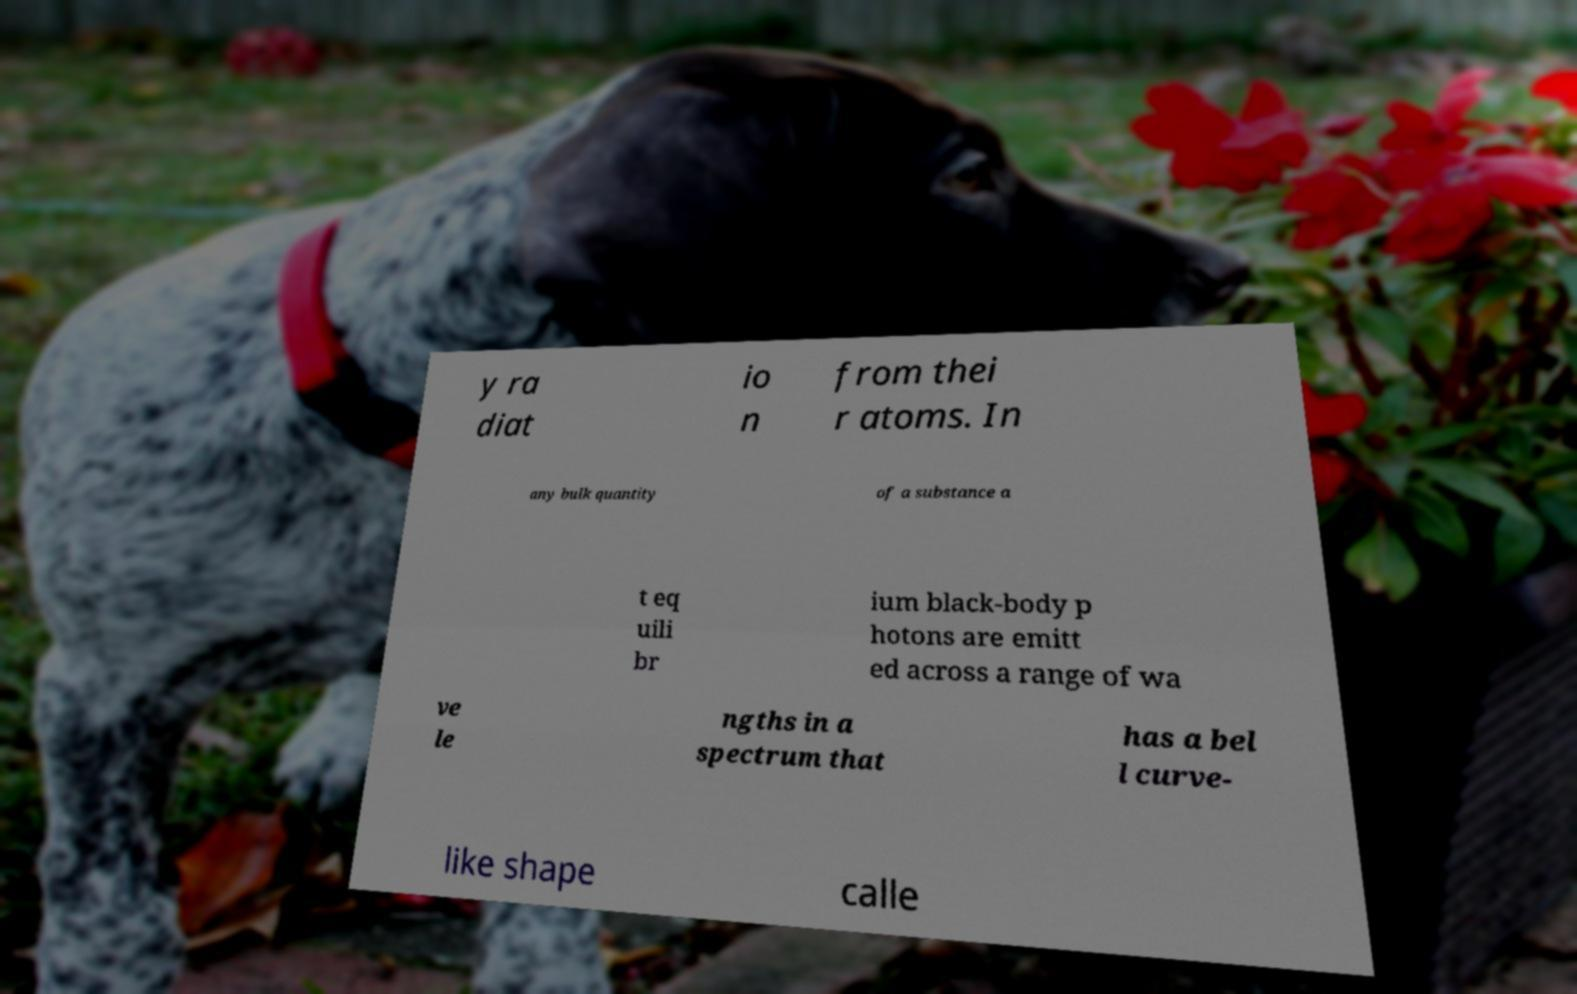I need the written content from this picture converted into text. Can you do that? y ra diat io n from thei r atoms. In any bulk quantity of a substance a t eq uili br ium black-body p hotons are emitt ed across a range of wa ve le ngths in a spectrum that has a bel l curve- like shape calle 